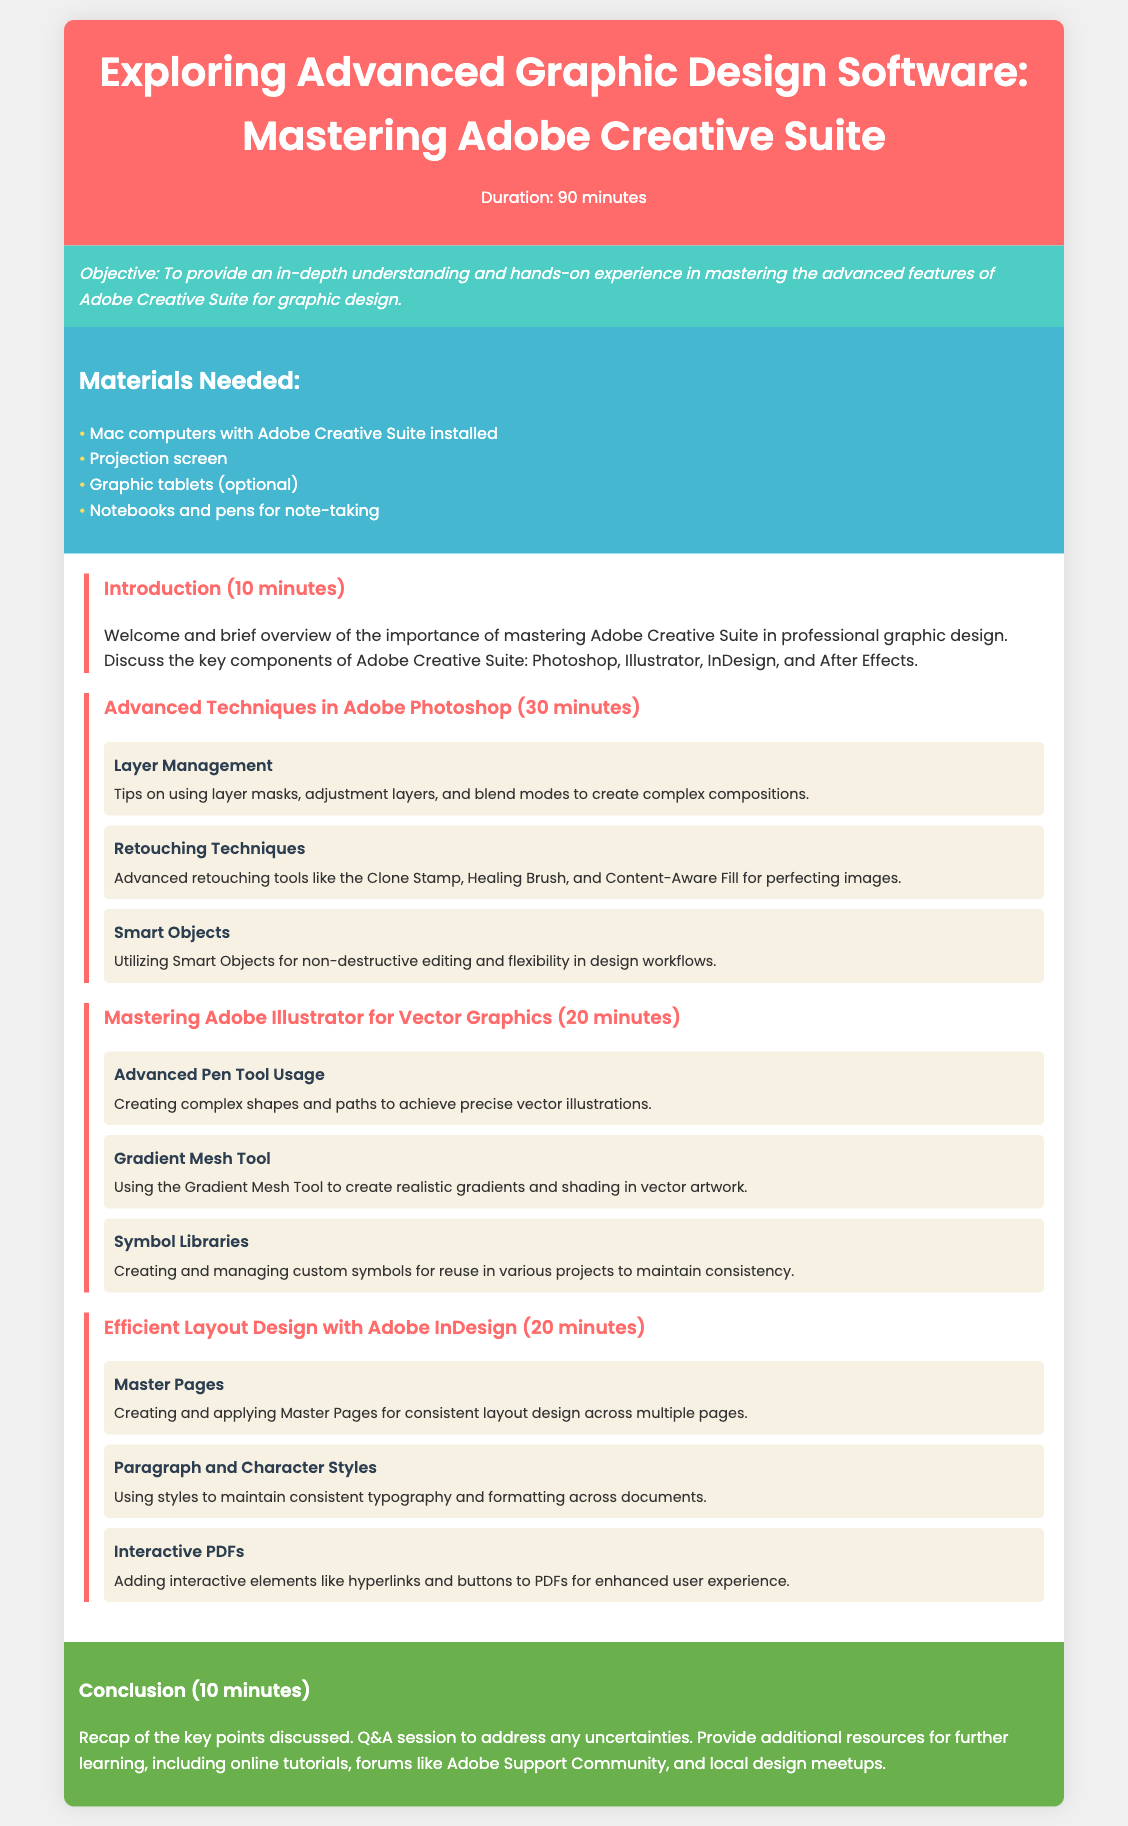What is the duration of the lesson? The duration of the lesson is specified in the document as 90 minutes.
Answer: 90 minutes What is the objective of the lesson? The document outlines that the objective is to provide an in-depth understanding and hands-on experience in mastering the advanced features of Adobe Creative Suite for graphic design.
Answer: To provide an in-depth understanding and hands-on experience Which Adobe software is mentioned for vector graphics? The document lists Adobe Illustrator as the software for mastering vector graphics.
Answer: Adobe Illustrator How long is the section on advanced techniques in Adobe Photoshop? The length of the section is provided in the document, which states it lasts for 30 minutes.
Answer: 30 minutes What optional material is suggested for the lesson? The document mentions graphic tablets as an optional material needed for the lesson.
Answer: Graphic tablets How many main sections are there in the lesson content? By counting the numbered sections in the lesson content, we find there are four main sections.
Answer: Four What tool is emphasized for creating complex shapes in Adobe Illustrator? The document highlights advanced pen tool usage for creating complex shapes and paths.
Answer: Advanced Pen Tool What is the focus of the Interactive PDFs topic? The document details that the focus is on adding interactive elements like hyperlinks and buttons to enhance user experience.
Answer: Adding interactive elements like hyperlinks and buttons What is the total time allocated for the conclusion session? The conclusion session time is specified as 10 minutes, as noted in the document.
Answer: 10 minutes 